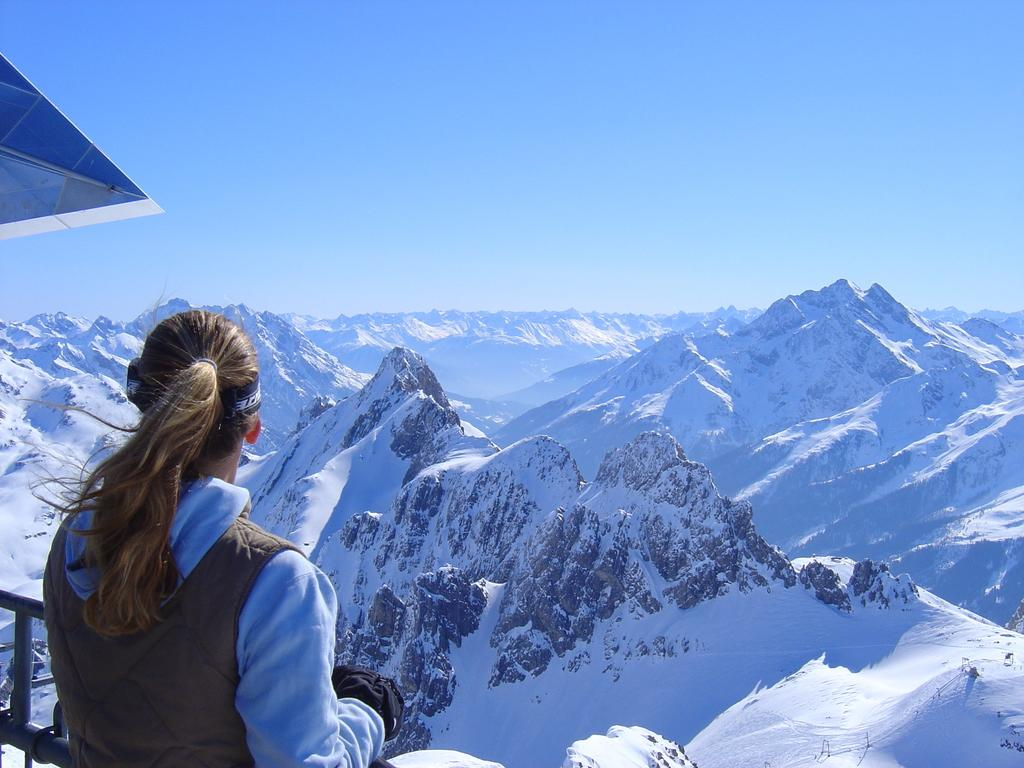Who is present in the image? There is a woman standing in the image. Where is the woman located in the image? The woman is on the bottom left side of the image. What can be seen in the background of the image? There are mountains in the background of the image. What is visible at the top of the image? The sky is visible at the top of the image. What type of rod is the woman holding in the middle of the image? There is no rod present in the image, and the woman is not holding anything. 